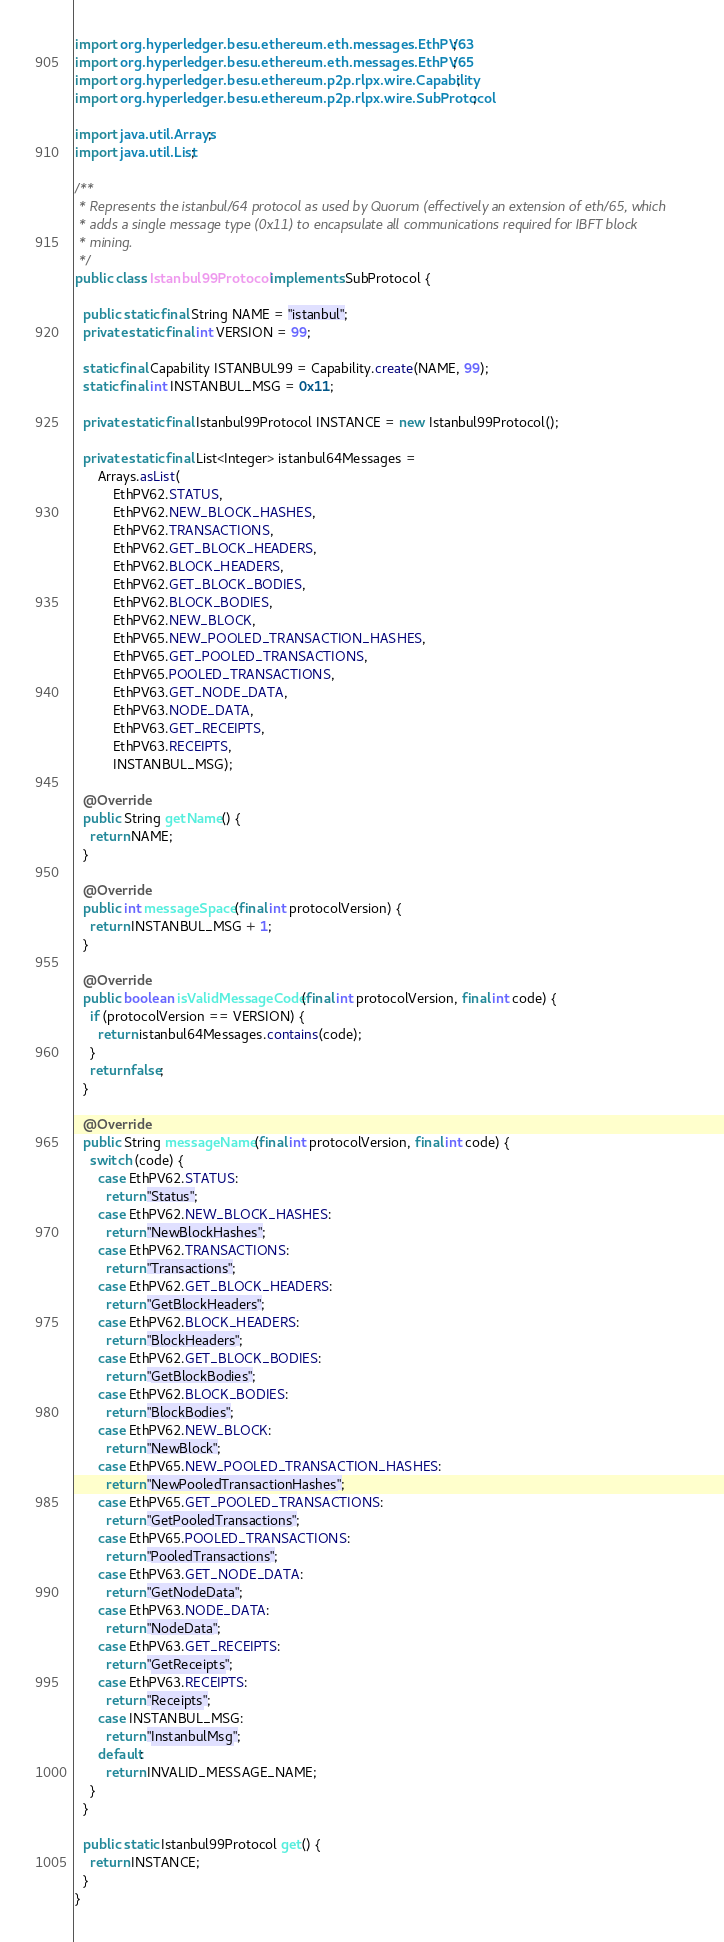<code> <loc_0><loc_0><loc_500><loc_500><_Java_>import org.hyperledger.besu.ethereum.eth.messages.EthPV63;
import org.hyperledger.besu.ethereum.eth.messages.EthPV65;
import org.hyperledger.besu.ethereum.p2p.rlpx.wire.Capability;
import org.hyperledger.besu.ethereum.p2p.rlpx.wire.SubProtocol;

import java.util.Arrays;
import java.util.List;

/**
 * Represents the istanbul/64 protocol as used by Quorum (effectively an extension of eth/65, which
 * adds a single message type (0x11) to encapsulate all communications required for IBFT block
 * mining.
 */
public class Istanbul99Protocol implements SubProtocol {

  public static final String NAME = "istanbul";
  private static final int VERSION = 99;

  static final Capability ISTANBUL99 = Capability.create(NAME, 99);
  static final int INSTANBUL_MSG = 0x11;

  private static final Istanbul99Protocol INSTANCE = new Istanbul99Protocol();

  private static final List<Integer> istanbul64Messages =
      Arrays.asList(
          EthPV62.STATUS,
          EthPV62.NEW_BLOCK_HASHES,
          EthPV62.TRANSACTIONS,
          EthPV62.GET_BLOCK_HEADERS,
          EthPV62.BLOCK_HEADERS,
          EthPV62.GET_BLOCK_BODIES,
          EthPV62.BLOCK_BODIES,
          EthPV62.NEW_BLOCK,
          EthPV65.NEW_POOLED_TRANSACTION_HASHES,
          EthPV65.GET_POOLED_TRANSACTIONS,
          EthPV65.POOLED_TRANSACTIONS,
          EthPV63.GET_NODE_DATA,
          EthPV63.NODE_DATA,
          EthPV63.GET_RECEIPTS,
          EthPV63.RECEIPTS,
          INSTANBUL_MSG);

  @Override
  public String getName() {
    return NAME;
  }

  @Override
  public int messageSpace(final int protocolVersion) {
    return INSTANBUL_MSG + 1;
  }

  @Override
  public boolean isValidMessageCode(final int protocolVersion, final int code) {
    if (protocolVersion == VERSION) {
      return istanbul64Messages.contains(code);
    }
    return false;
  }

  @Override
  public String messageName(final int protocolVersion, final int code) {
    switch (code) {
      case EthPV62.STATUS:
        return "Status";
      case EthPV62.NEW_BLOCK_HASHES:
        return "NewBlockHashes";
      case EthPV62.TRANSACTIONS:
        return "Transactions";
      case EthPV62.GET_BLOCK_HEADERS:
        return "GetBlockHeaders";
      case EthPV62.BLOCK_HEADERS:
        return "BlockHeaders";
      case EthPV62.GET_BLOCK_BODIES:
        return "GetBlockBodies";
      case EthPV62.BLOCK_BODIES:
        return "BlockBodies";
      case EthPV62.NEW_BLOCK:
        return "NewBlock";
      case EthPV65.NEW_POOLED_TRANSACTION_HASHES:
        return "NewPooledTransactionHashes";
      case EthPV65.GET_POOLED_TRANSACTIONS:
        return "GetPooledTransactions";
      case EthPV65.POOLED_TRANSACTIONS:
        return "PooledTransactions";
      case EthPV63.GET_NODE_DATA:
        return "GetNodeData";
      case EthPV63.NODE_DATA:
        return "NodeData";
      case EthPV63.GET_RECEIPTS:
        return "GetReceipts";
      case EthPV63.RECEIPTS:
        return "Receipts";
      case INSTANBUL_MSG:
        return "InstanbulMsg";
      default:
        return INVALID_MESSAGE_NAME;
    }
  }

  public static Istanbul99Protocol get() {
    return INSTANCE;
  }
}
</code> 